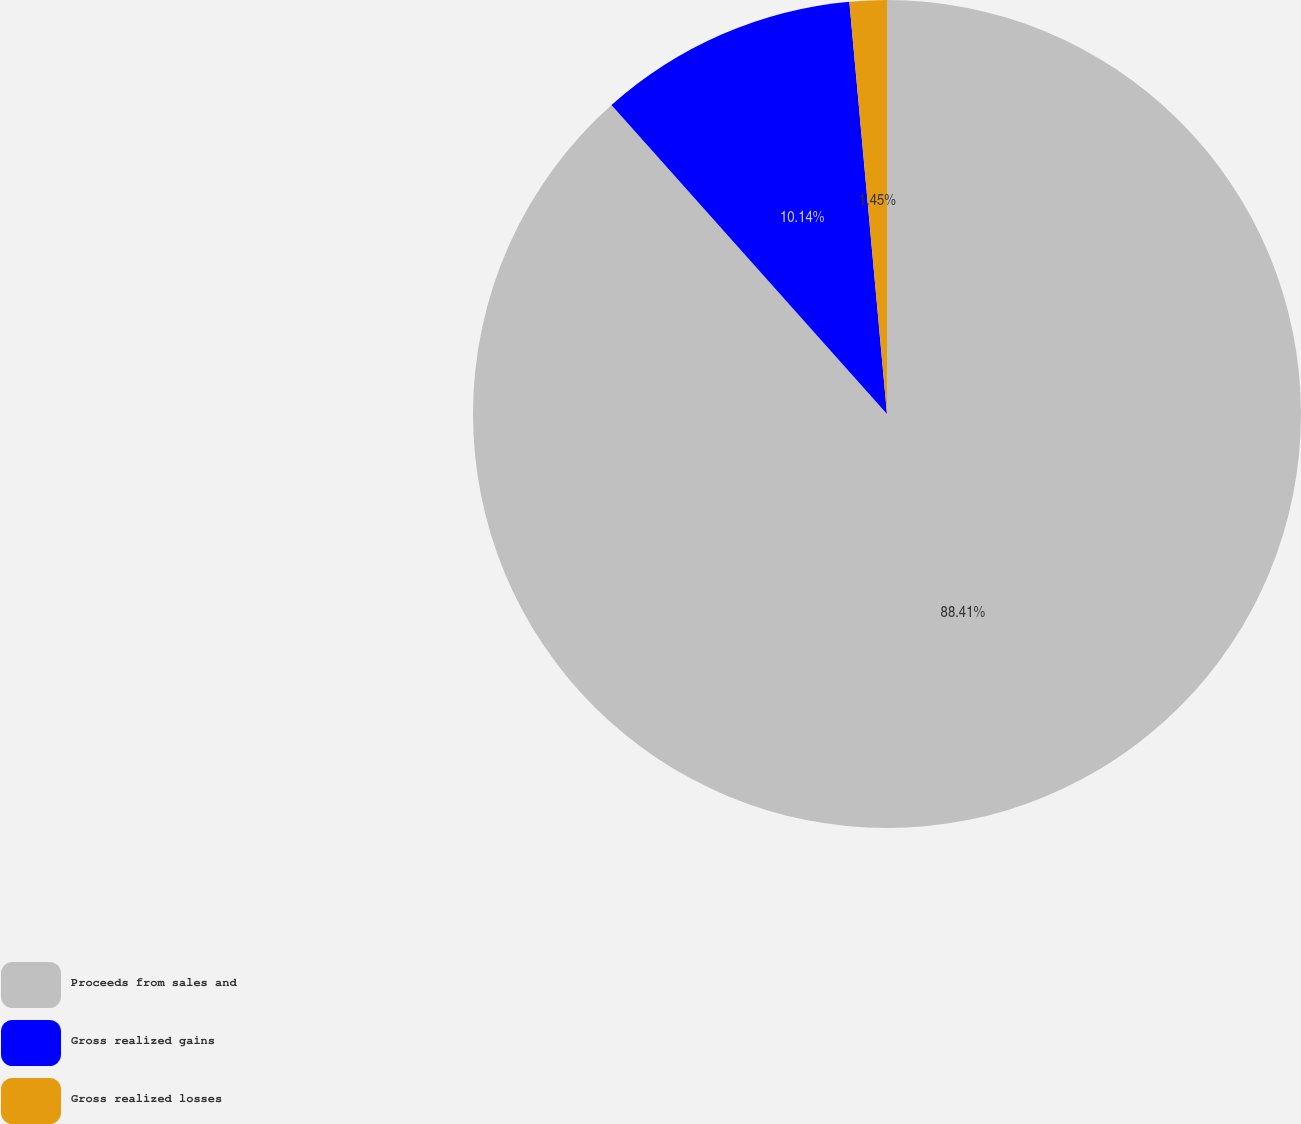<chart> <loc_0><loc_0><loc_500><loc_500><pie_chart><fcel>Proceeds from sales and<fcel>Gross realized gains<fcel>Gross realized losses<nl><fcel>88.41%<fcel>10.14%<fcel>1.45%<nl></chart> 